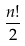<formula> <loc_0><loc_0><loc_500><loc_500>\frac { n ! } { 2 }</formula> 